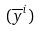<formula> <loc_0><loc_0><loc_500><loc_500>( \overline { y } ^ { i } )</formula> 